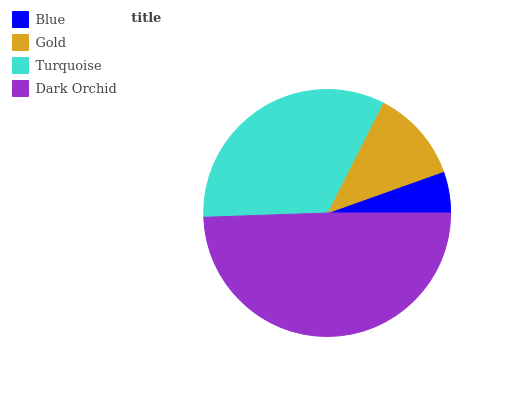Is Blue the minimum?
Answer yes or no. Yes. Is Dark Orchid the maximum?
Answer yes or no. Yes. Is Gold the minimum?
Answer yes or no. No. Is Gold the maximum?
Answer yes or no. No. Is Gold greater than Blue?
Answer yes or no. Yes. Is Blue less than Gold?
Answer yes or no. Yes. Is Blue greater than Gold?
Answer yes or no. No. Is Gold less than Blue?
Answer yes or no. No. Is Turquoise the high median?
Answer yes or no. Yes. Is Gold the low median?
Answer yes or no. Yes. Is Blue the high median?
Answer yes or no. No. Is Blue the low median?
Answer yes or no. No. 